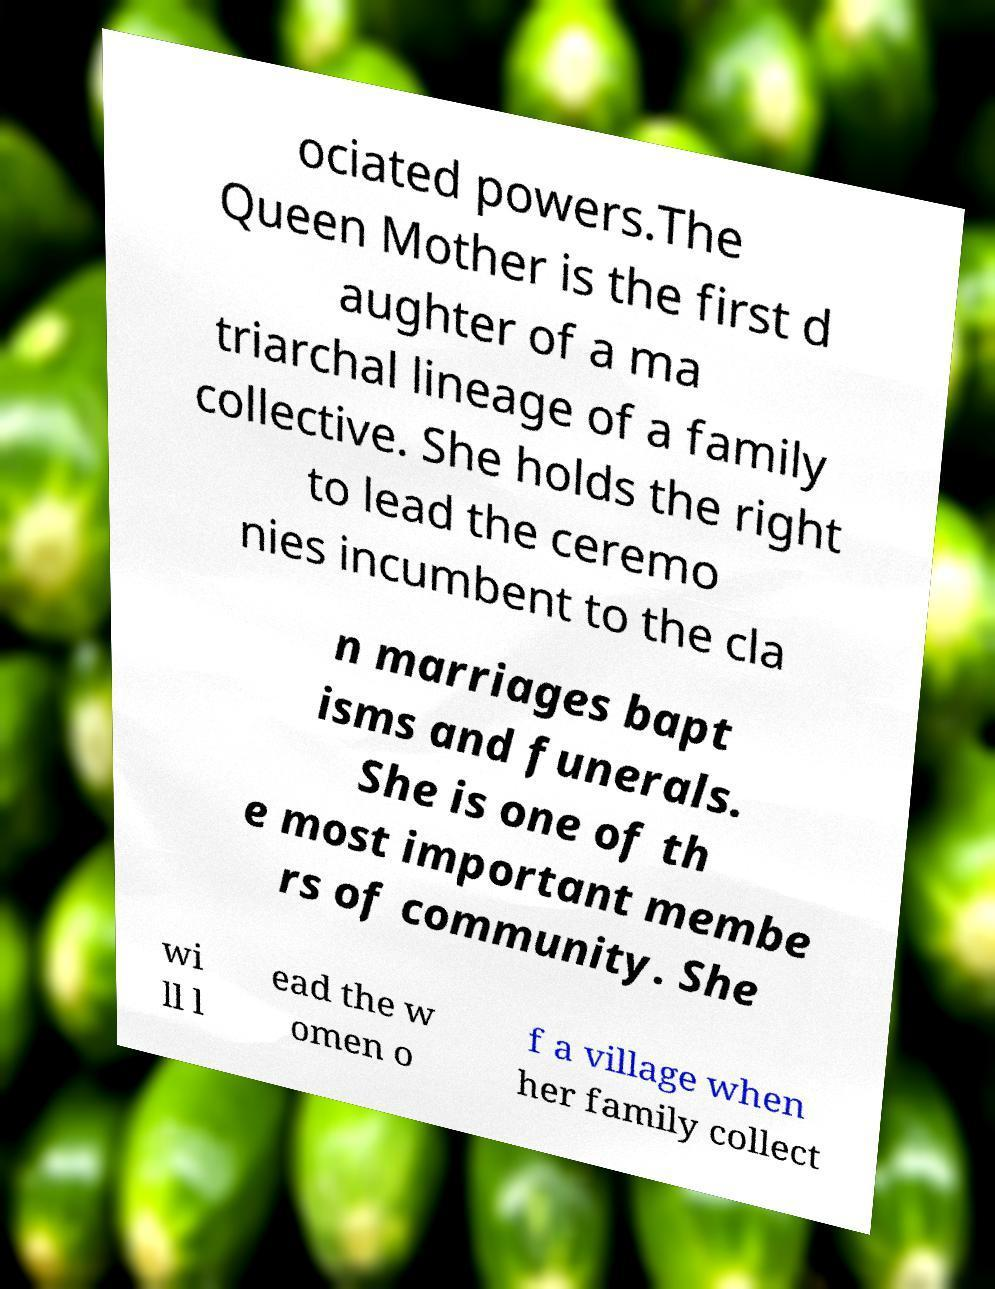Could you assist in decoding the text presented in this image and type it out clearly? ociated powers.The Queen Mother is the first d aughter of a ma triarchal lineage of a family collective. She holds the right to lead the ceremo nies incumbent to the cla n marriages bapt isms and funerals. She is one of th e most important membe rs of community. She wi ll l ead the w omen o f a village when her family collect 